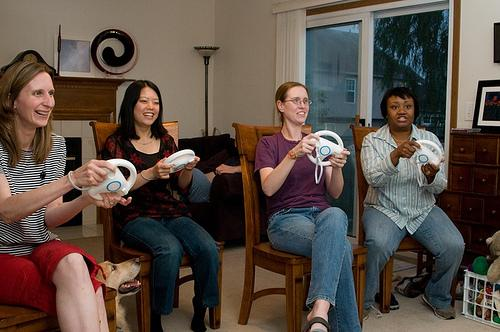What activity is the video game system simulating?

Choices:
A) baseball
B) driving
C) basketball
D) karate driving 